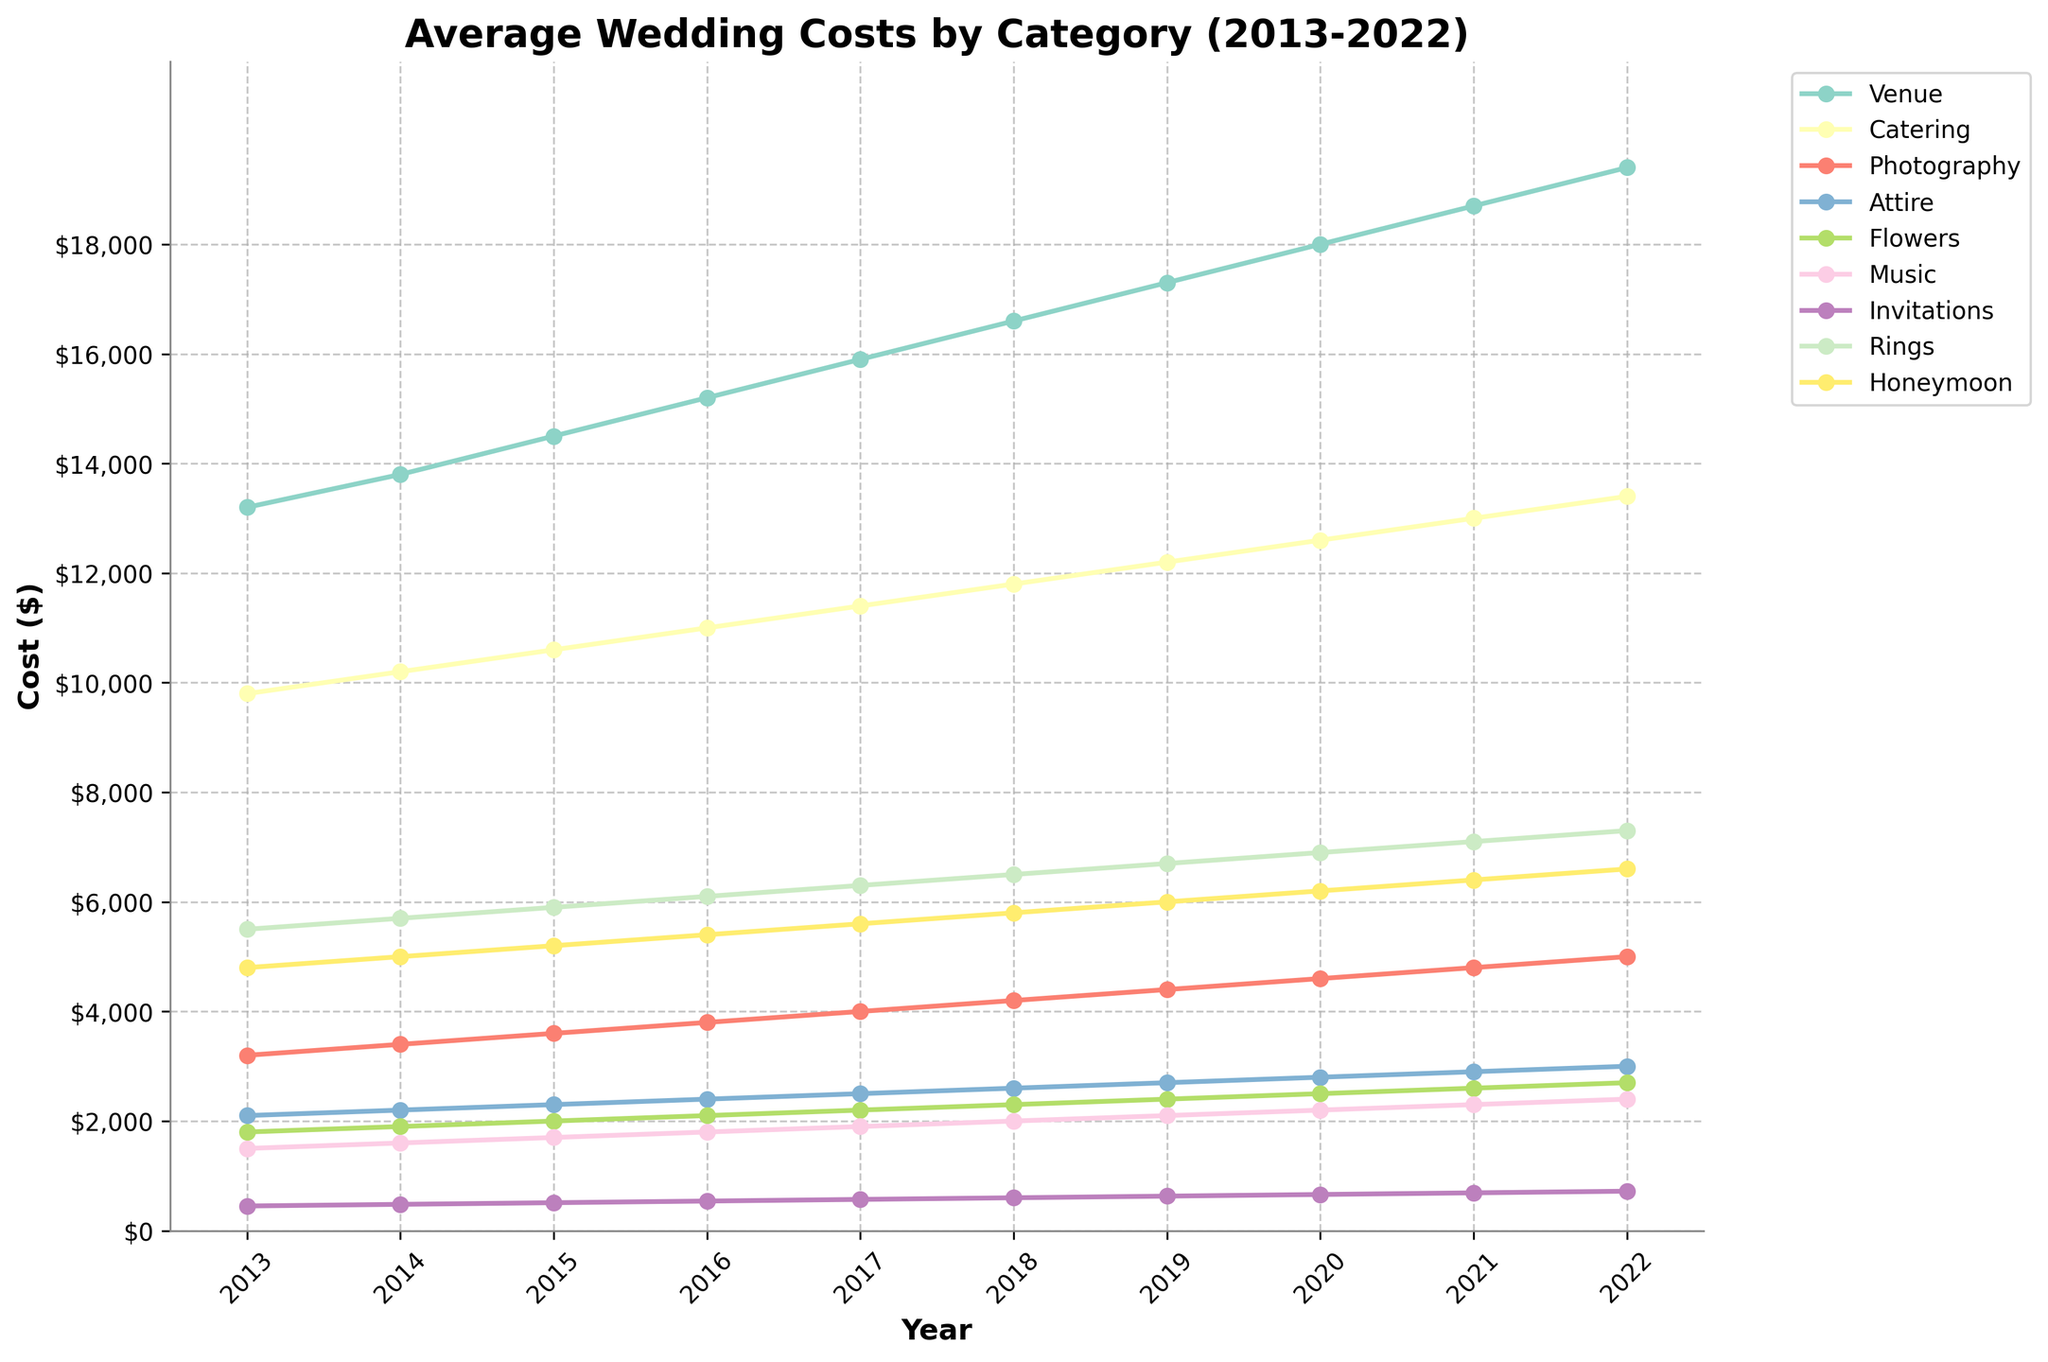What's the trend in the average cost of the Venue from 2013 to 2022? Observe the line corresponding to the Venue category. It consistently increases from $13,200 in 2013 to $19,400 in 2022. The trend is upward.
Answer: Upward Which expense category had the least cost each year? Look for the line that remains the lowest across all years. The Invitations category consistently has the lowest cost each year compared to other categories.
Answer: Invitations By how much did the Photography cost increase from 2013 to 2022? Check the Photography points in 2013 and 2022. The cost in 2013 was $3,200, and in 2022 it was $5,000. The increase is $5,000 - $3,200 = $1,800.
Answer: $1,800 Which years did the cost of Catering and Photography increase the most? Observe the steepest slopes for Catering and Photography. The largest increase for Catering was from 2021 to 2022 ($13,400 - $13,000 = $400). For Photography, the largest increase was also from 2021 to 2022 ($5,000 - $4,800 = $200).
Answer: 2021 to 2022 What is the highest cost recorded for the Flowers category, and in which year did it occur? Identify the peak point on the Flowers line. The highest cost was $2,700 in 2022.
Answer: $2,700 in 2022 Which category saw the smallest increase in costs from 2013 to 2022? Calculate the increase for each category from 2013 to 2022. The smallest increase is for the Invitations category, which went from $450 in 2013 to $720 in 2022, an increase of $270.
Answer: Invitations How do the costs of Rings and Honeymoon compare in 2019? Look at the points for Rings and Honeymoon in 2019. Rings cost $6,700 and Honeymoon cost $6,000. The Rings cost more.
Answer: Rings cost more What's the difference in the average cost of Attire between 2014 and 2019? Check the Attire values for 2014 and 2019. The cost in 2014 is $2,200 and in 2019 it's $2,700. The difference is $2,700 - $2,200 = $500.
Answer: $500 What is the overall trend in the cost of Music from 2013 to 2022? Observe the Music category line. It shows a steady increase from $1,500 in 2013 to $2,400 in 2022. The overall trend is upward.
Answer: Upward Which year had the highest average total costs across all categories, and what is that total? Add the costs for each year and compare. For 2022, the sum is $19,400 + $13,400 + $5,000 + $3,000 + $2,700 + $2,400 + $720 + $7,300 + $6,600 = $60,520. All other years have totals below this.
Answer: 2022, $60,520 